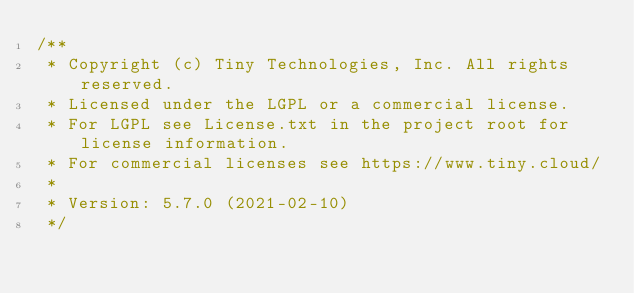<code> <loc_0><loc_0><loc_500><loc_500><_JavaScript_>/**
 * Copyright (c) Tiny Technologies, Inc. All rights reserved.
 * Licensed under the LGPL or a commercial license.
 * For LGPL see License.txt in the project root for license information.
 * For commercial licenses see https://www.tiny.cloud/
 *
 * Version: 5.7.0 (2021-02-10)
 */</code> 